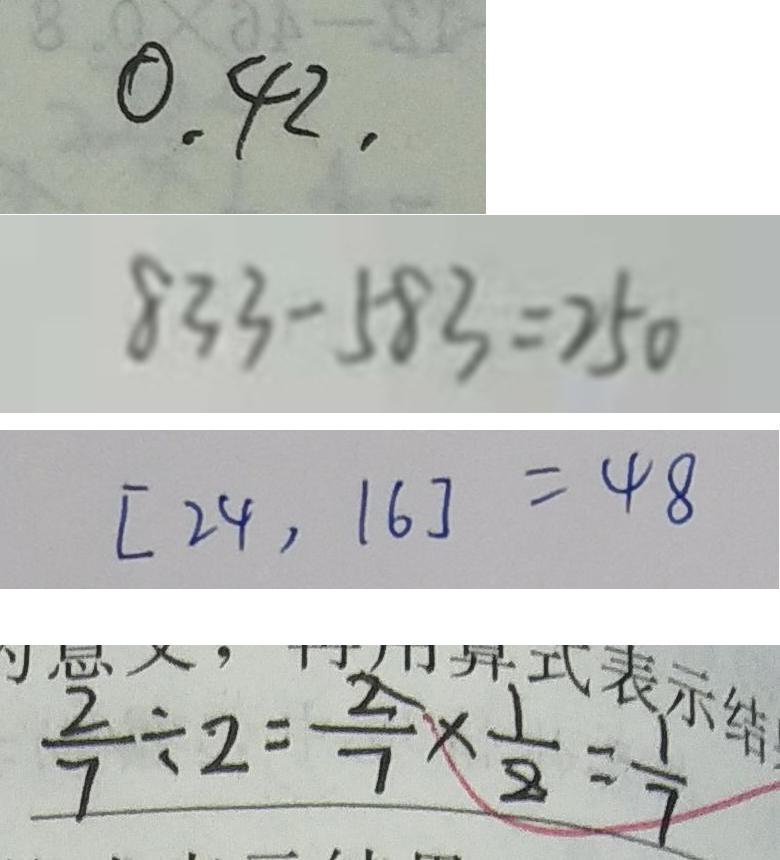<formula> <loc_0><loc_0><loc_500><loc_500>0 . 4 2 , 
 8 3 3 - 5 8 3 = 2 5 0 
 [ 2 4 , 1 6 ] = 4 8 
 \frac { 2 } { 7 } \div 2 = \frac { 2 } { 7 } \times \frac { 1 } { 8 } = \frac { 1 } { 7 }</formula> 